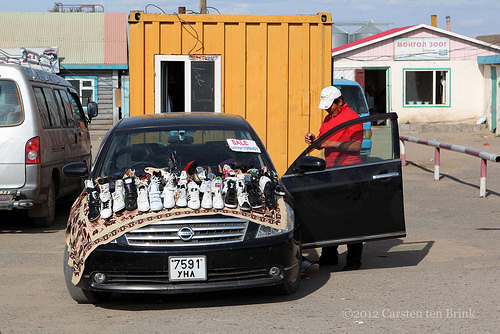<image>
Can you confirm if the car is under the rug? Yes. The car is positioned underneath the rug, with the rug above it in the vertical space. Is there a person behind the car? Yes. From this viewpoint, the person is positioned behind the car, with the car partially or fully occluding the person. Where is the car in relation to the man? Is it to the right of the man? No. The car is not to the right of the man. The horizontal positioning shows a different relationship. 